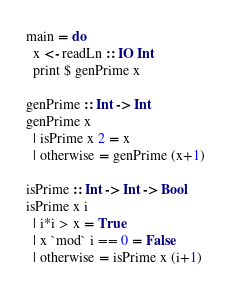<code> <loc_0><loc_0><loc_500><loc_500><_Haskell_>main = do
  x <- readLn :: IO Int
  print $ genPrime x

genPrime :: Int -> Int
genPrime x
  | isPrime x 2 = x
  | otherwise = genPrime (x+1)

isPrime :: Int -> Int -> Bool
isPrime x i 
  | i*i > x = True
  | x `mod` i == 0 = False
  | otherwise = isPrime x (i+1)</code> 